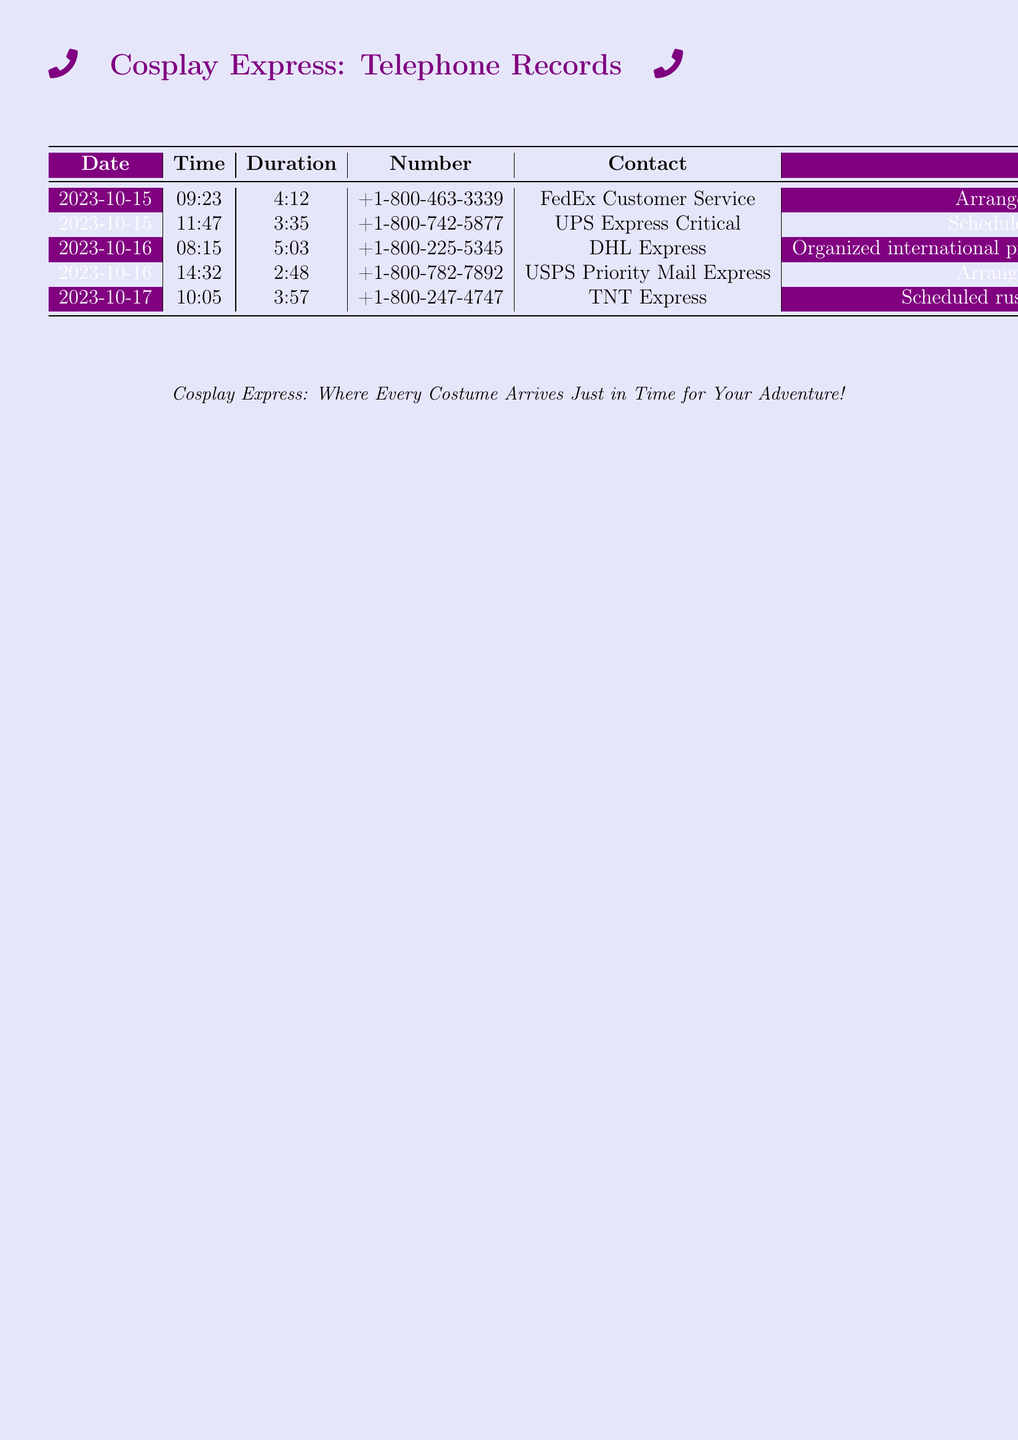what is the date of the first call? The date of the first call is listed in the first row of the table, which corresponds to the earliest entry.
Answer: 2023-10-15 who was the contact for the second call? The contact for the second call is taken from the second row in the table, identifying the person or company communicated with.
Answer: UPS Express Critical how long did the call to FedEx customer service last? The duration of the call to FedEx customer service is recorded in the duration column of the first row.
Answer: 4:12 how many calls were made on October 16th? The total number of calls is determined by checking the entries corresponding to the date October 16th in the table.
Answer: 2 which service was used for the My Hero Academia costumes delivery? The service for the delivery of My Hero Academia costumes is mentioned in the notes of the respective row in the table.
Answer: TNT Express what type of costumes were shipped to Anime Expo? The type of costumes shipped is detailed in the notes for the call to DHL Express, describing the nature of the shipment.
Answer: Attack on Titan Survey Corps jackets which location received next-day delivery? The location for the next-day delivery is identified in the notes of the call to USPS Priority Mail Express.
Answer: Dragon Con in Atlanta how many different courier services were used? The number of different courier services can be found by counting the unique entries in the contact column.
Answer: 5 